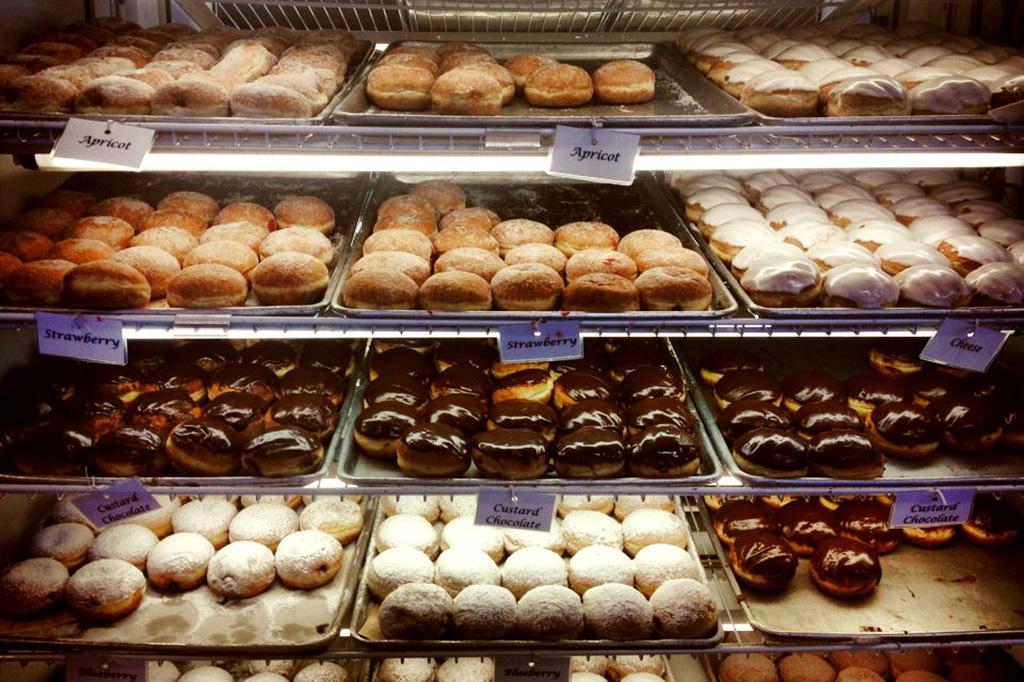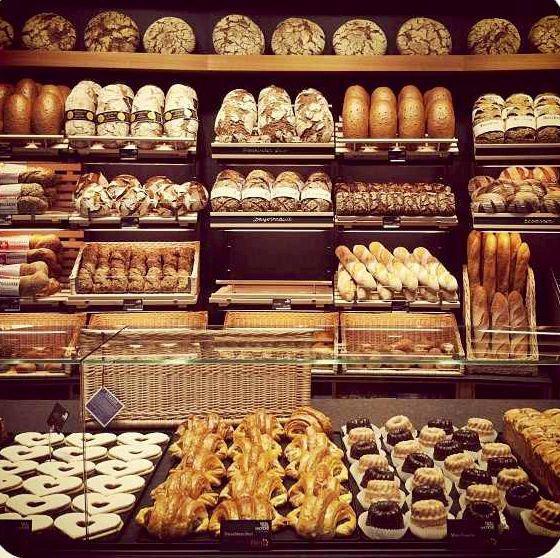The first image is the image on the left, the second image is the image on the right. Evaluate the accuracy of this statement regarding the images: "Shelves of baked goods are shown up close in both images.". Is it true? Answer yes or no. Yes. The first image is the image on the left, the second image is the image on the right. For the images displayed, is the sentence "A black chalkboard advertises items next to a food display in one bakery." factually correct? Answer yes or no. No. 